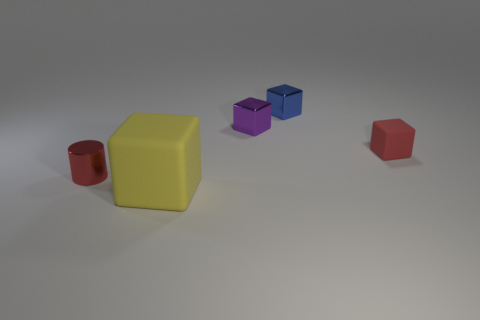Add 2 small red rubber cubes. How many objects exist? 7 Subtract all cylinders. How many objects are left? 4 Add 1 red objects. How many red objects exist? 3 Subtract 1 purple cubes. How many objects are left? 4 Subtract all tiny cyan shiny balls. Subtract all small rubber blocks. How many objects are left? 4 Add 3 cylinders. How many cylinders are left? 4 